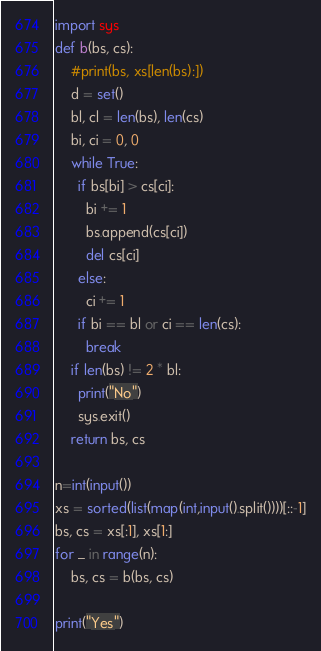<code> <loc_0><loc_0><loc_500><loc_500><_Python_>import sys
def b(bs, cs):
    #print(bs, xs[len(bs):])
    d = set()
    bl, cl = len(bs), len(cs)
    bi, ci = 0, 0
    while True:
      if bs[bi] > cs[ci]:
        bi += 1
        bs.append(cs[ci])
        del cs[ci]
      else:
        ci += 1
      if bi == bl or ci == len(cs):
        break
    if len(bs) != 2 * bl:
      print("No")
      sys.exit()
    return bs, cs

n=int(input())
xs = sorted(list(map(int,input().split())))[::-1]
bs, cs = xs[:1], xs[1:]
for _ in range(n):
    bs, cs = b(bs, cs)

print("Yes")


</code> 